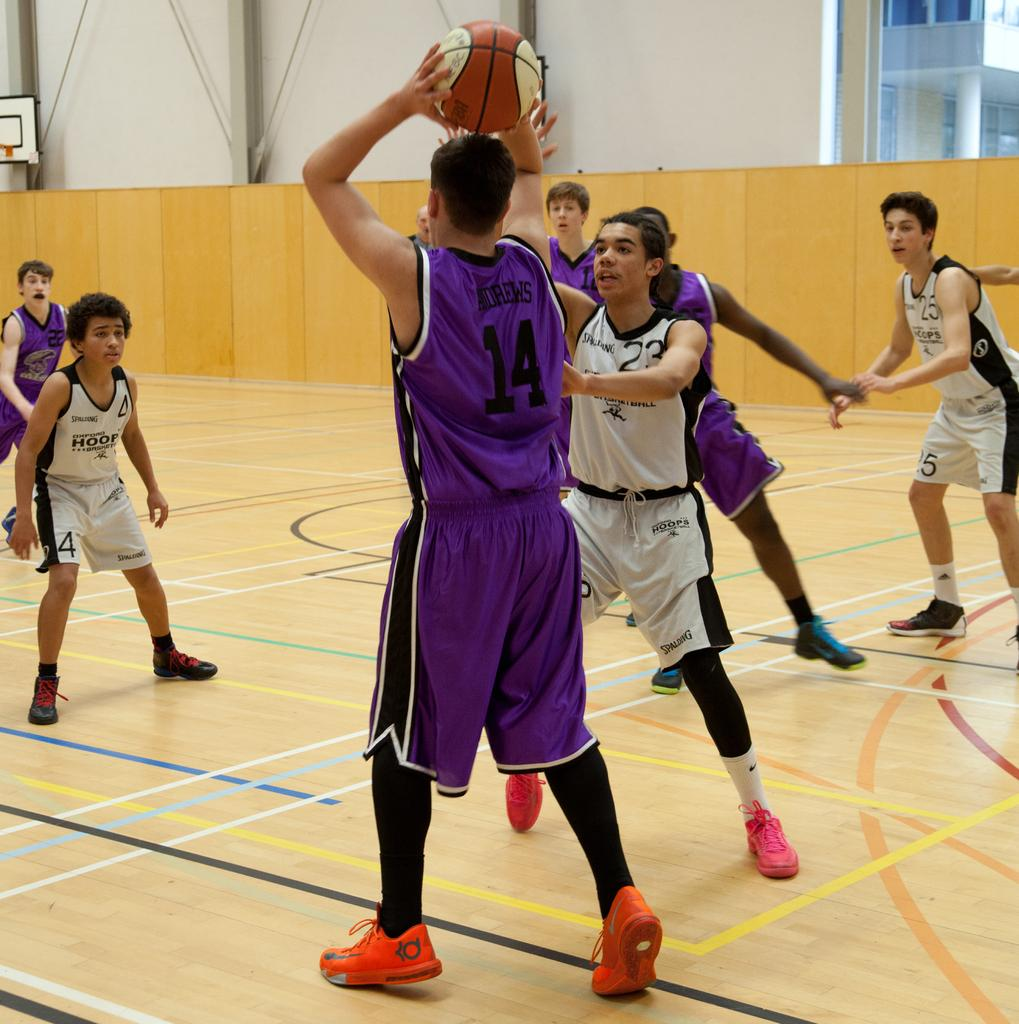What type of area is depicted in the image? There is a court in the picture. What are the children doing on the court? The children are playing with a ball on the court. Can you describe any other features in the image? There is a wall in the picture. What is the price of the chairs in the image? There are no chairs present in the image, so it is not possible to determine the price of any chairs. 